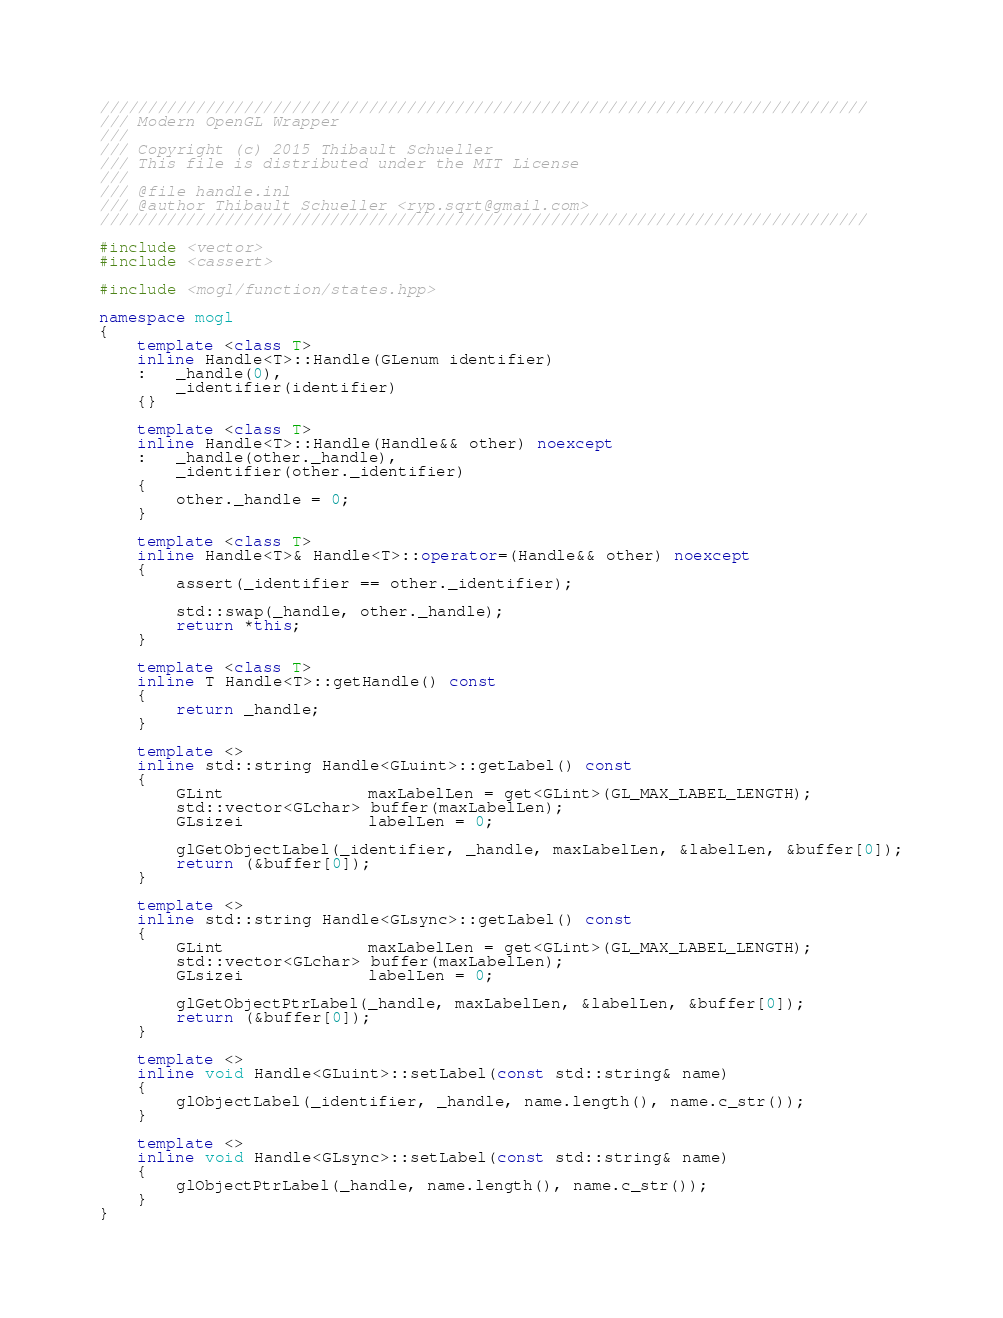<code> <loc_0><loc_0><loc_500><loc_500><_C++_>////////////////////////////////////////////////////////////////////////////////
/// Modern OpenGL Wrapper
///
/// Copyright (c) 2015 Thibault Schueller
/// This file is distributed under the MIT License
///
/// @file handle.inl
/// @author Thibault Schueller <ryp.sqrt@gmail.com>
////////////////////////////////////////////////////////////////////////////////

#include <vector>
#include <cassert>

#include <mogl/function/states.hpp>

namespace mogl
{
    template <class T>
    inline Handle<T>::Handle(GLenum identifier)
    :   _handle(0),
        _identifier(identifier)
    {}

    template <class T>
    inline Handle<T>::Handle(Handle&& other) noexcept
    :   _handle(other._handle),
        _identifier(other._identifier)
    {
        other._handle = 0;
    }

    template <class T>
    inline Handle<T>& Handle<T>::operator=(Handle&& other) noexcept
    {
        assert(_identifier == other._identifier);

        std::swap(_handle, other._handle);
        return *this;
    }

    template <class T>
    inline T Handle<T>::getHandle() const
    {
        return _handle;
    }

    template <>
    inline std::string Handle<GLuint>::getLabel() const
    {
        GLint               maxLabelLen = get<GLint>(GL_MAX_LABEL_LENGTH);
        std::vector<GLchar> buffer(maxLabelLen);
        GLsizei             labelLen = 0;

        glGetObjectLabel(_identifier, _handle, maxLabelLen, &labelLen, &buffer[0]);
        return (&buffer[0]);
    }

    template <>
    inline std::string Handle<GLsync>::getLabel() const
    {
        GLint               maxLabelLen = get<GLint>(GL_MAX_LABEL_LENGTH);
        std::vector<GLchar> buffer(maxLabelLen);
        GLsizei             labelLen = 0;

        glGetObjectPtrLabel(_handle, maxLabelLen, &labelLen, &buffer[0]);
        return (&buffer[0]);
    }

    template <>
    inline void Handle<GLuint>::setLabel(const std::string& name)
    {
        glObjectLabel(_identifier, _handle, name.length(), name.c_str());
    }

    template <>
    inline void Handle<GLsync>::setLabel(const std::string& name)
    {
        glObjectPtrLabel(_handle, name.length(), name.c_str());
    }
}
</code> 